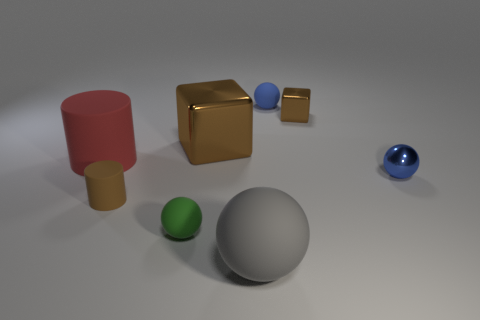Subtract all red spheres. Subtract all yellow blocks. How many spheres are left? 4 Add 1 big red matte things. How many objects exist? 9 Subtract all cylinders. How many objects are left? 6 Add 5 small brown blocks. How many small brown blocks are left? 6 Add 5 tiny yellow metal things. How many tiny yellow metal things exist? 5 Subtract 0 red spheres. How many objects are left? 8 Subtract all tiny green rubber things. Subtract all rubber balls. How many objects are left? 4 